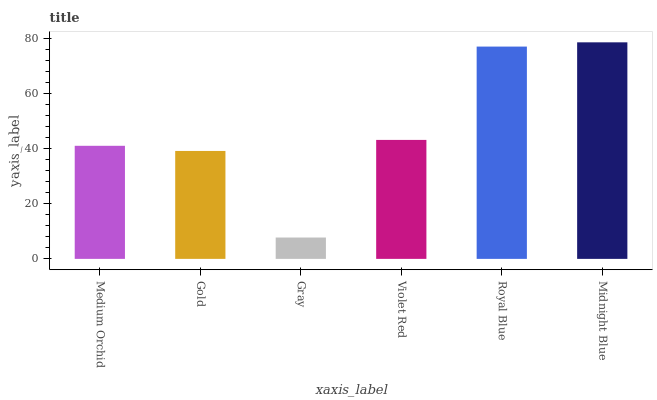Is Gray the minimum?
Answer yes or no. Yes. Is Midnight Blue the maximum?
Answer yes or no. Yes. Is Gold the minimum?
Answer yes or no. No. Is Gold the maximum?
Answer yes or no. No. Is Medium Orchid greater than Gold?
Answer yes or no. Yes. Is Gold less than Medium Orchid?
Answer yes or no. Yes. Is Gold greater than Medium Orchid?
Answer yes or no. No. Is Medium Orchid less than Gold?
Answer yes or no. No. Is Violet Red the high median?
Answer yes or no. Yes. Is Medium Orchid the low median?
Answer yes or no. Yes. Is Royal Blue the high median?
Answer yes or no. No. Is Violet Red the low median?
Answer yes or no. No. 